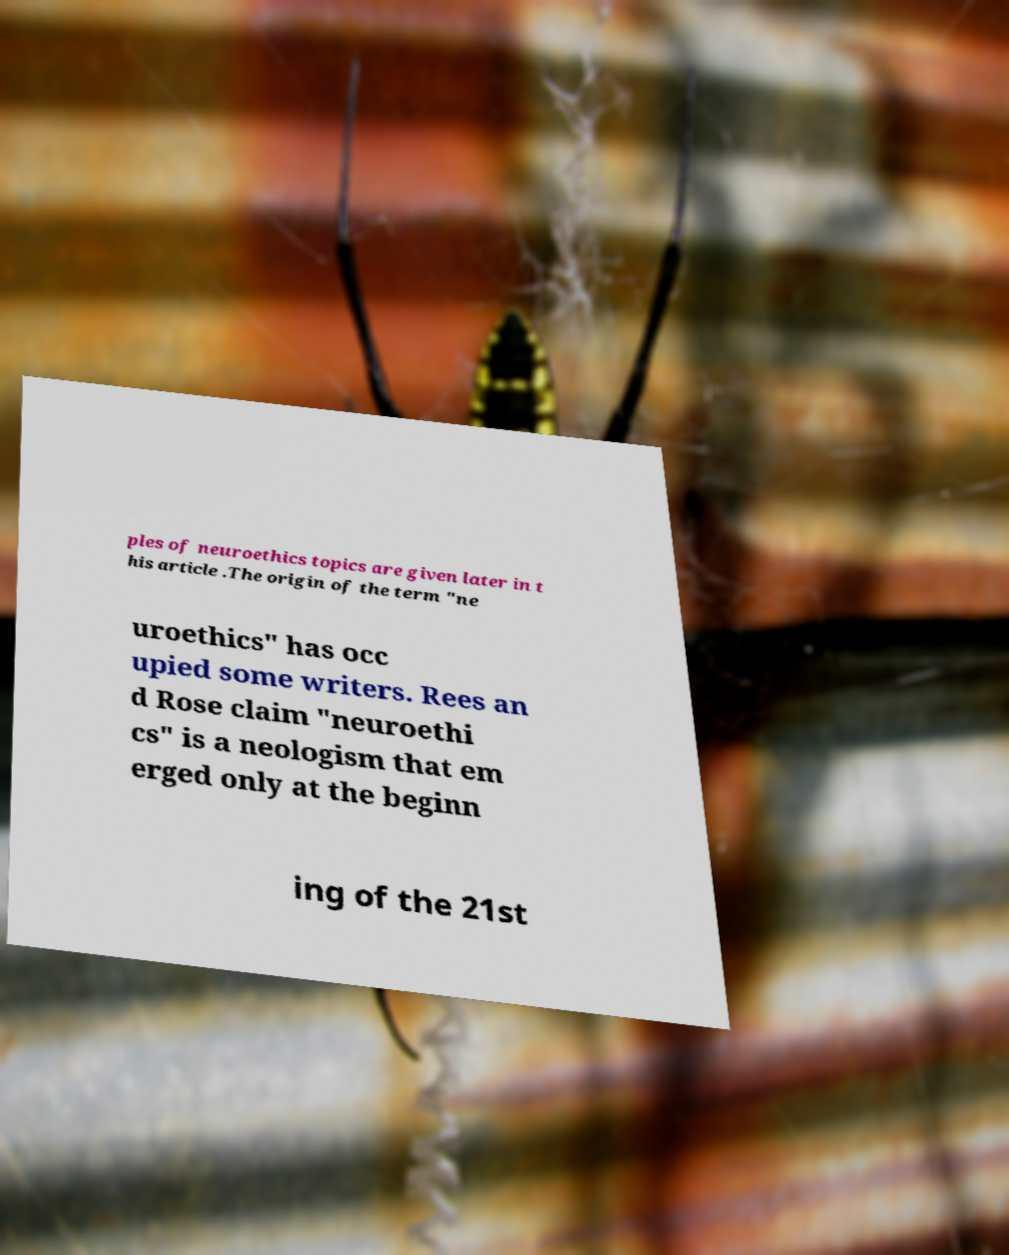Can you accurately transcribe the text from the provided image for me? ples of neuroethics topics are given later in t his article .The origin of the term "ne uroethics" has occ upied some writers. Rees an d Rose claim "neuroethi cs" is a neologism that em erged only at the beginn ing of the 21st 